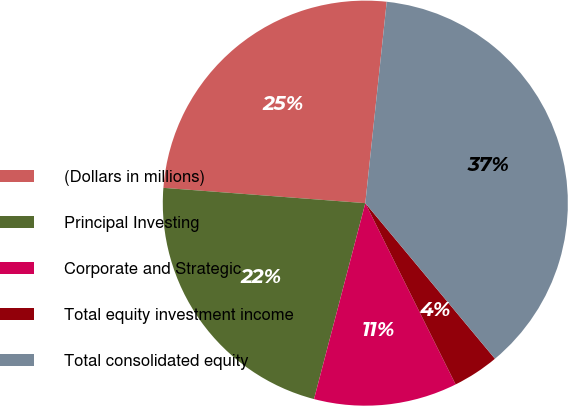Convert chart to OTSL. <chart><loc_0><loc_0><loc_500><loc_500><pie_chart><fcel>(Dollars in millions)<fcel>Principal Investing<fcel>Corporate and Strategic<fcel>Total equity investment income<fcel>Total consolidated equity<nl><fcel>25.48%<fcel>22.13%<fcel>11.43%<fcel>3.7%<fcel>37.26%<nl></chart> 